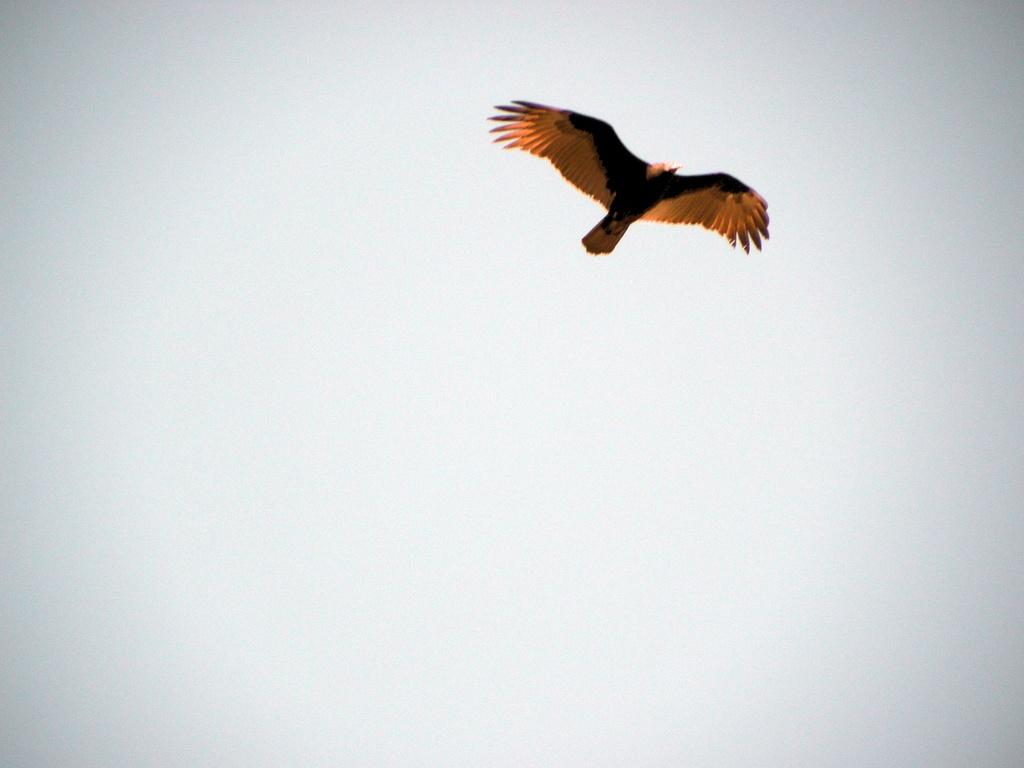What is the main subject of the image? There is a bird in the image. What is the bird doing in the image? The bird is flying in the sky. What type of kite is the bird's partner in the image? There is no kite or partner present in the image; it features a bird flying in the sky. What sound does the bird make in the image? The image does not provide any information about the sound the bird might make. 